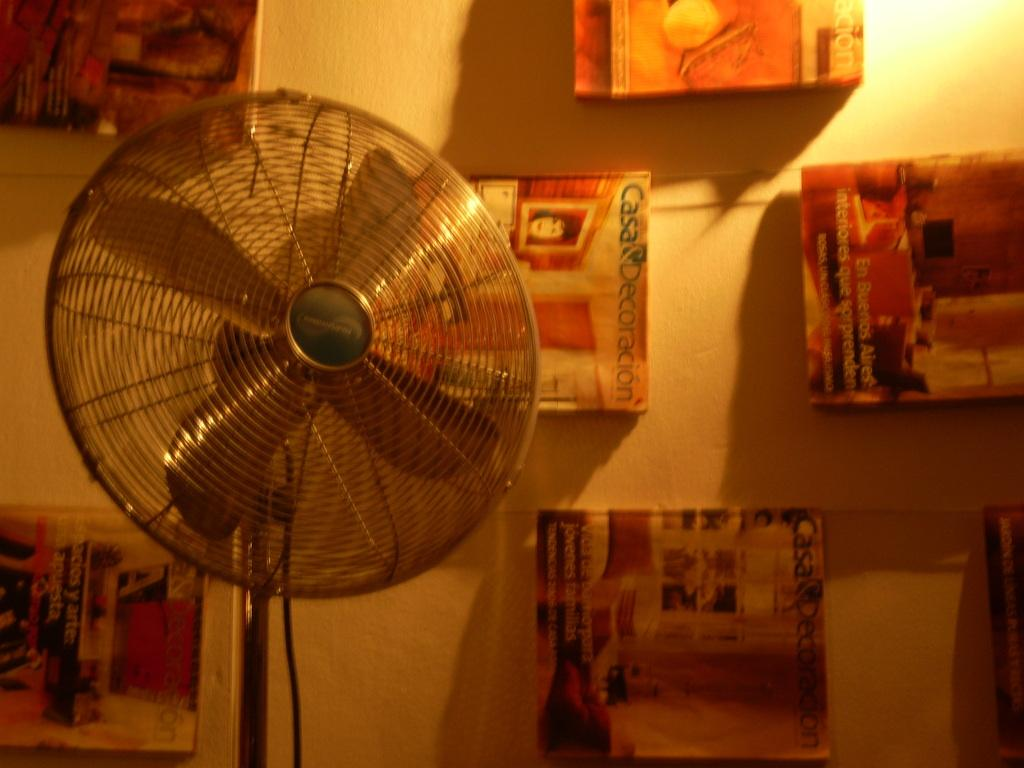Provide a one-sentence caption for the provided image. a wall with casa decorations magazines is shown. 